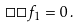<formula> <loc_0><loc_0><loc_500><loc_500>\Box \Box f _ { 1 } = 0 \, .</formula> 